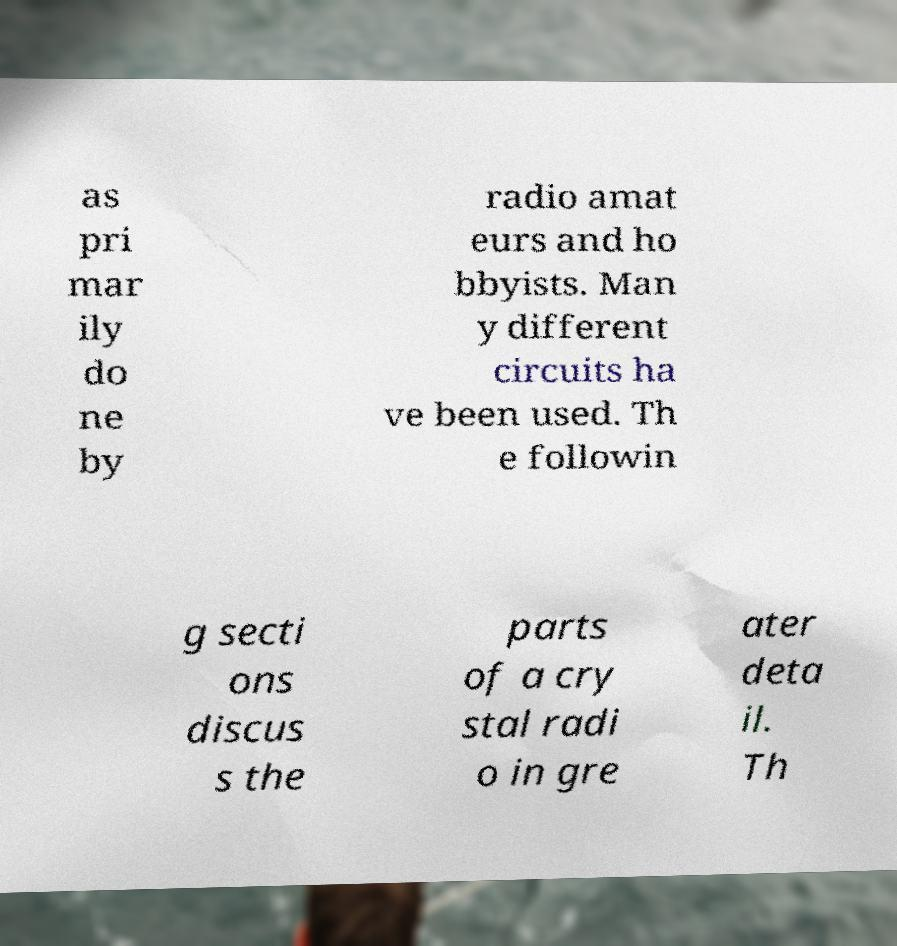There's text embedded in this image that I need extracted. Can you transcribe it verbatim? as pri mar ily do ne by radio amat eurs and ho bbyists. Man y different circuits ha ve been used. Th e followin g secti ons discus s the parts of a cry stal radi o in gre ater deta il. Th 